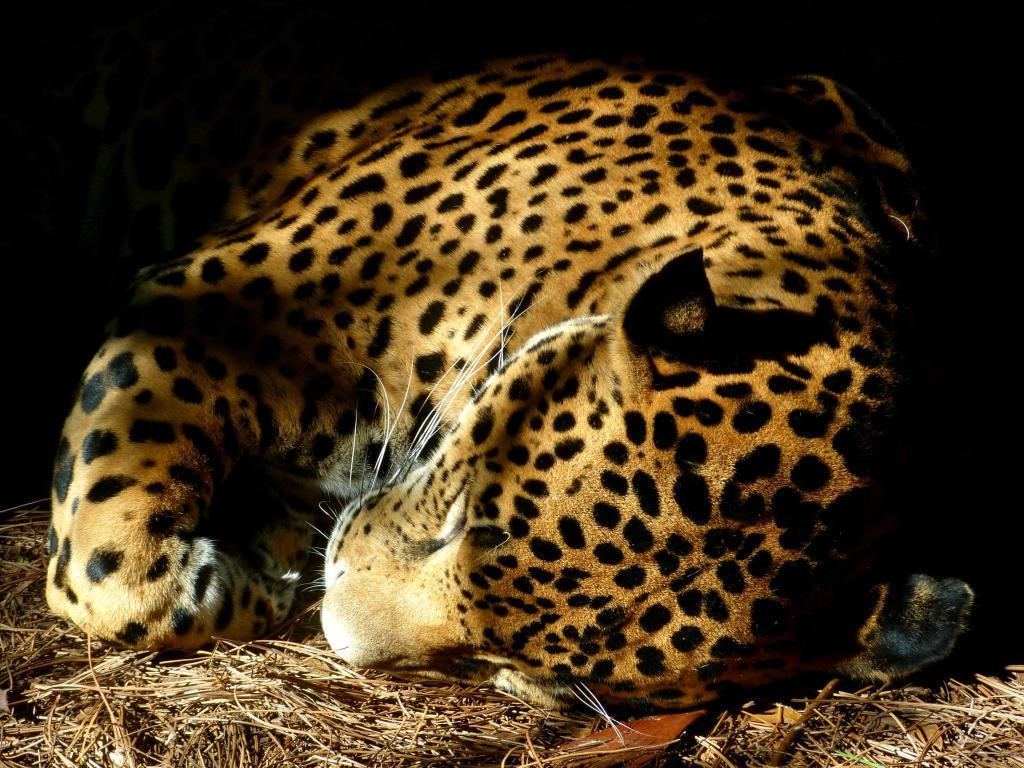What animal can be seen in the image? There is a leopard in the image. What is the leopard doing in the image? The leopard is sleeping. What type of terrain is the leopard resting on? The leopard is on dry grass. What can be observed about the lighting in the image? The background of the image is dark. What type of juice is being served at the church in the image? There is no church or juice present in the image; it features a leopard sleeping on dry grass with a dark background. 